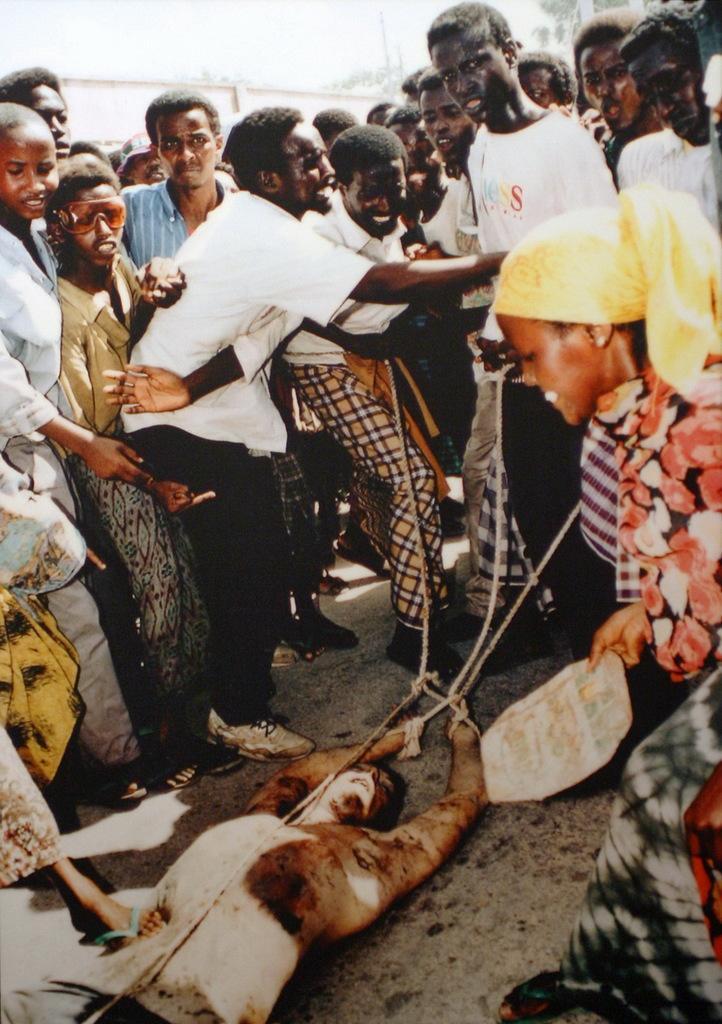Describe this image in one or two sentences. In this picture we can see the group of men and women, standing on the road and giving the punishment to the man. In the center we can see the man lying on the road and hands are tied with the rope. 